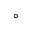<formula> <loc_0><loc_0><loc_500><loc_500>^ { \circ }</formula> 